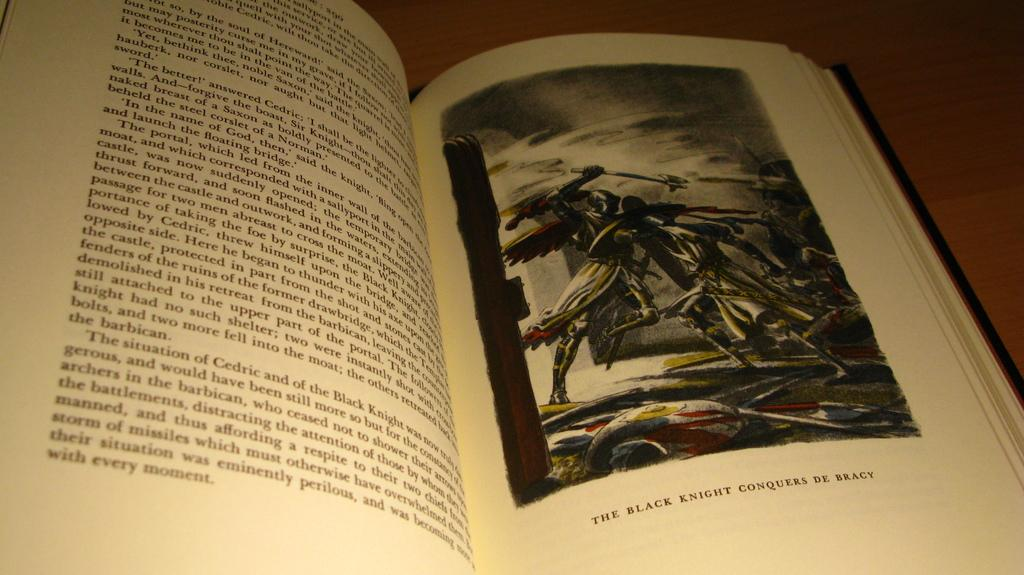<image>
Provide a brief description of the given image. A book is open to an illustration of the black knight. 